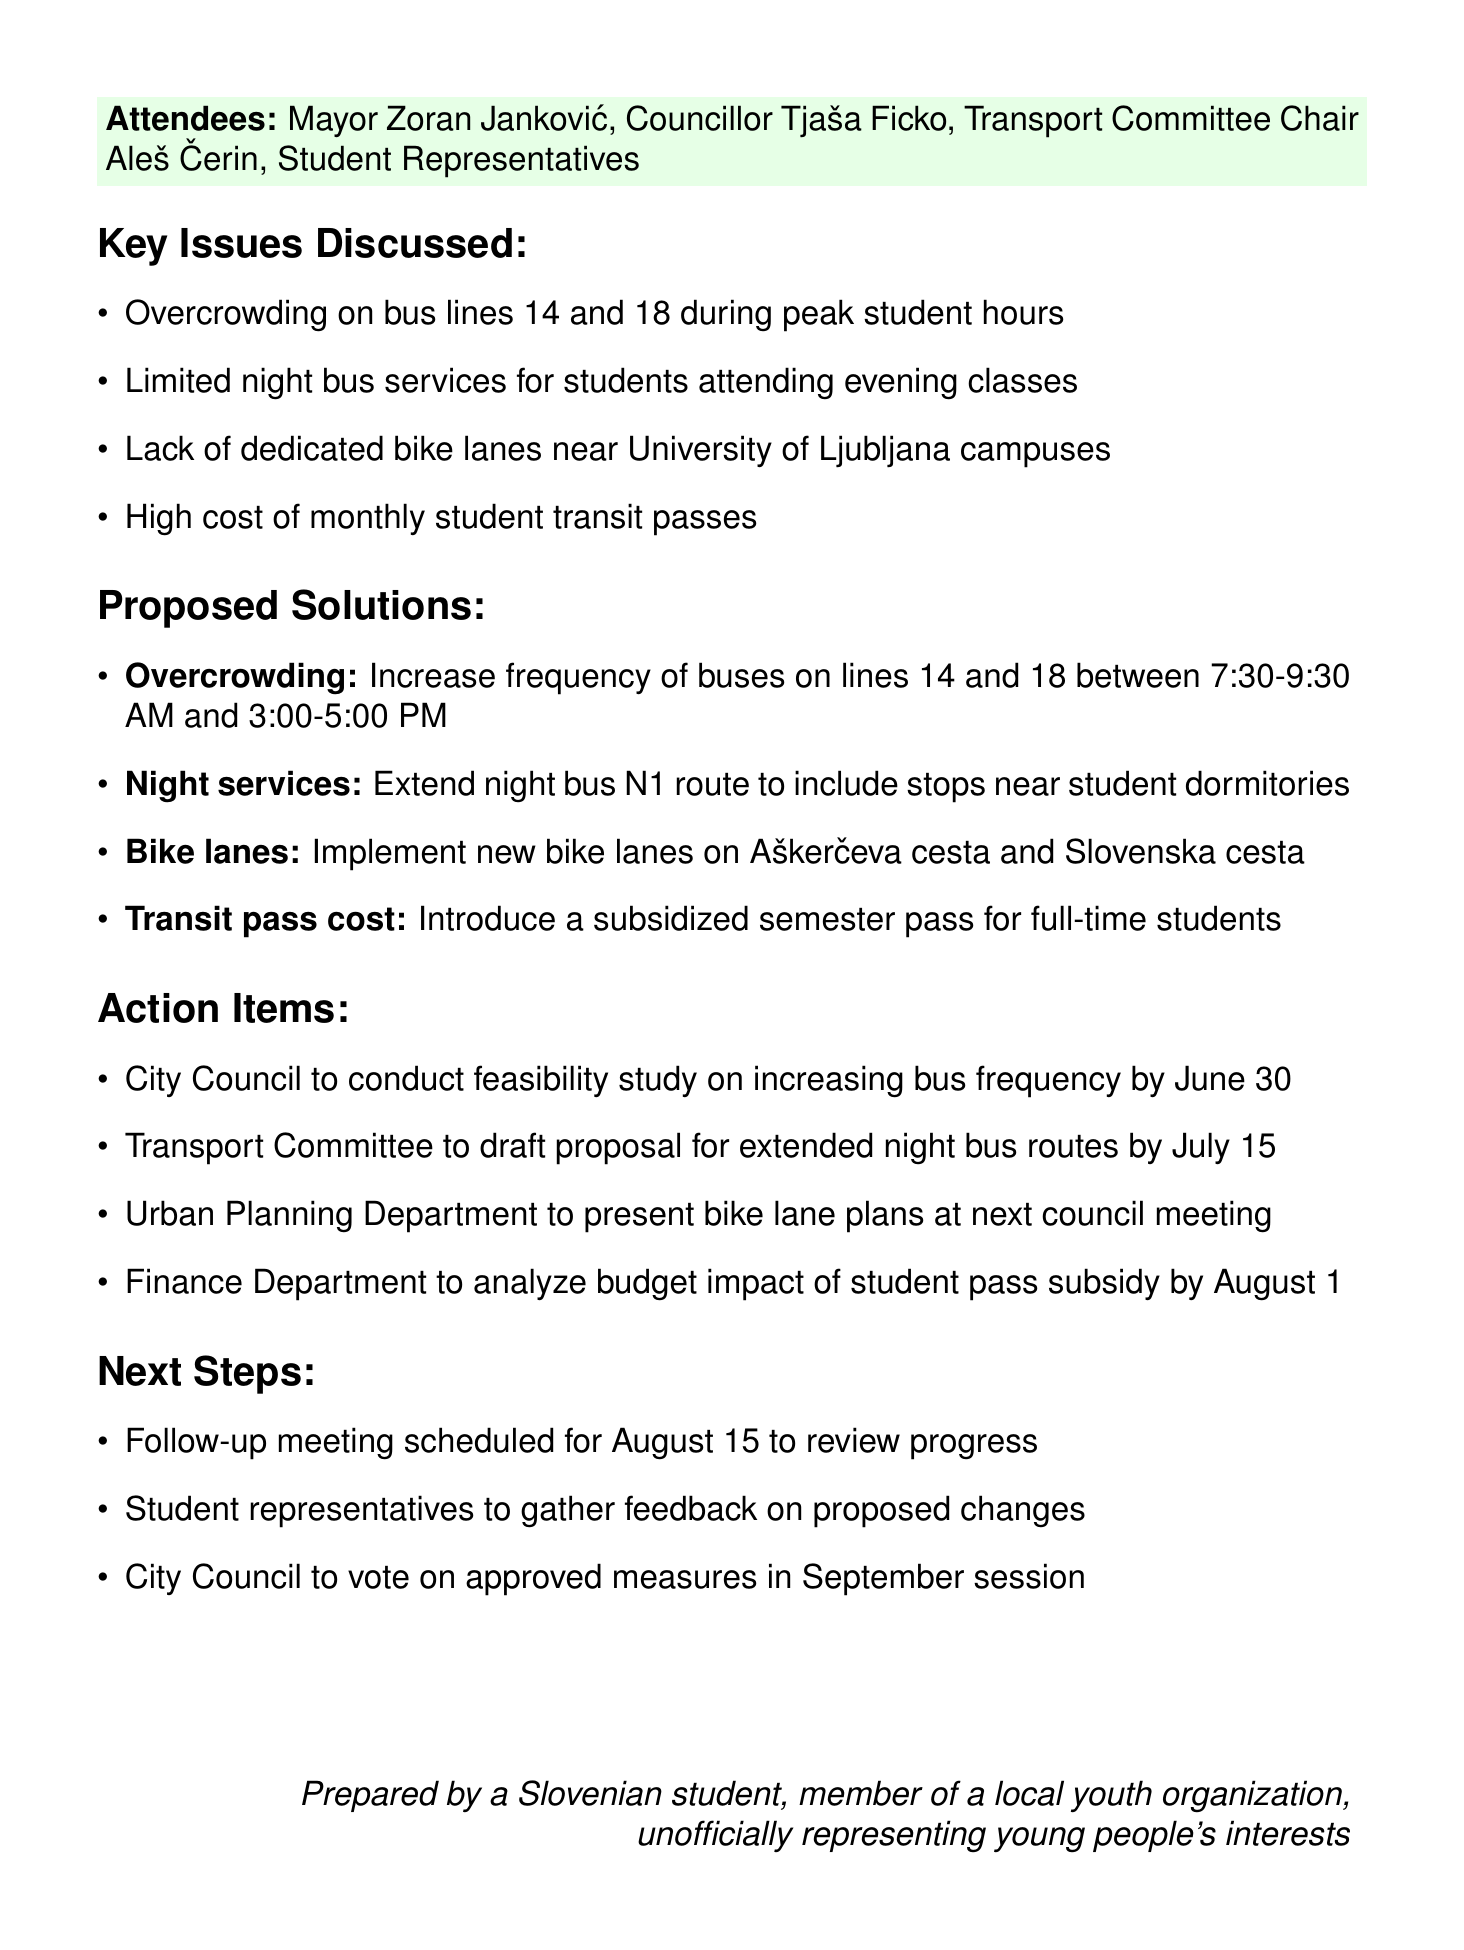What was the date of the meeting? The meeting was held on May 15, 2023, as stated in the document.
Answer: May 15, 2023 Who is the Mayor of Ljubljana? The document lists Mayor Zoran Janković as one of the attendees.
Answer: Zoran Janković Which bus lines are mentioned as overcrowded? The key issues discuss overcrowding specifically on lines 14 and 18.
Answer: 14 and 18 What is the proposed solution for the high cost of transit passes? The solution suggests introducing a subsidized semester pass for full-time students.
Answer: Subsidized semester pass When is the follow-up meeting scheduled? The follow-up meeting is scheduled for August 15, as noted in the next steps section.
Answer: August 15 What department is responsible for presenting bike lane plans? The Urban Planning Department is tasked with presenting the bike lane plans at the next council meeting.
Answer: Urban Planning Department What time frame was proposed to increase bus frequency on lines 14 and 18? The proposed increase in frequency is between 7:30-9:30 AM and 3:00-5:00 PM.
Answer: 7:30-9:30 AM and 3:00-5:00 PM What is one of the main issues discussed related to biking? The document mentions a lack of dedicated bike lanes near University of Ljubljana campuses as a key issue.
Answer: Lack of dedicated bike lanes When is the city council expected to vote on approved measures? The city council is scheduled to vote on approved measures in the September session.
Answer: September session 